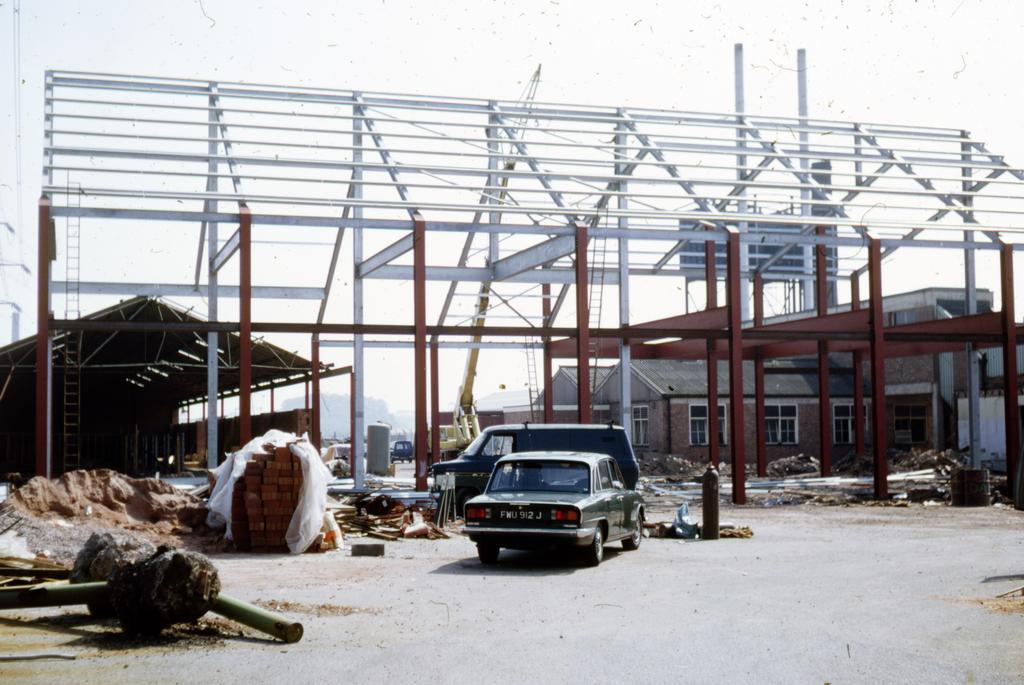Describe this image in one or two sentences. In this image I can see the ground, two vehicles on the ground, few metal poles on the ground, few bricks, some sand and a building which is under construction. In the background I can see a shed, few buildings, a crane, few other vehicles and the sky. 